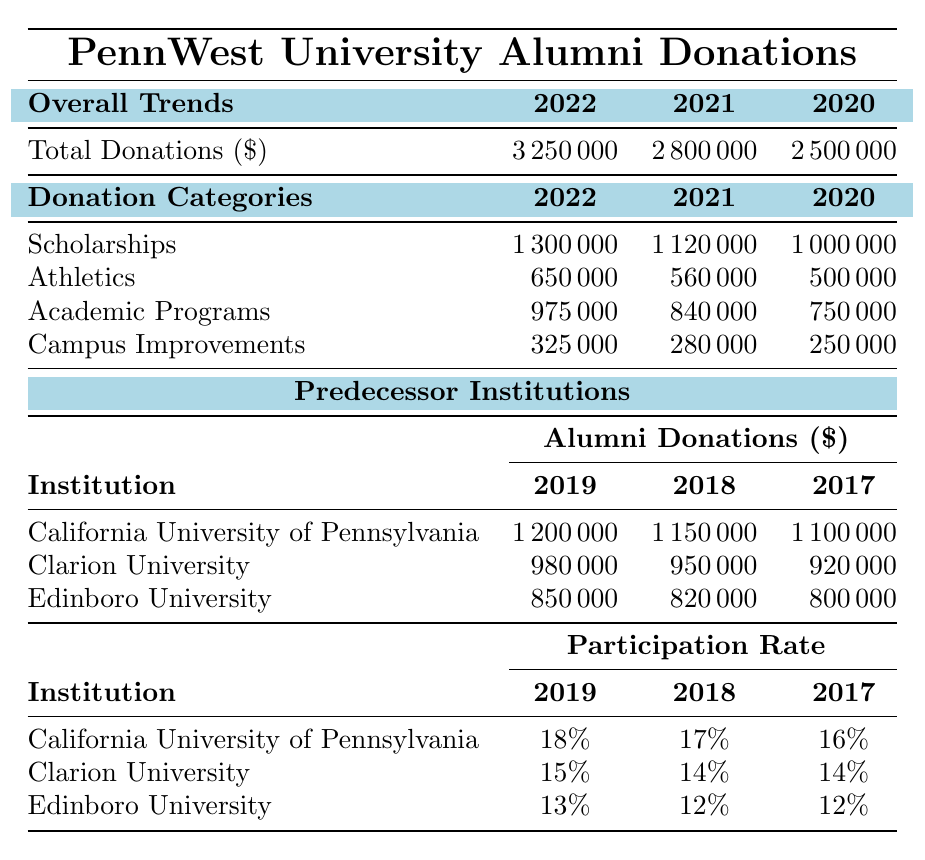What was the total alumni donation for PennWest University in 2022? The table indicates that the total alumni donations for PennWest University in 2022 is listed as $3,250,000.
Answer: $3,250,000 What was the participation rate for California University of Pennsylvania in 2019? The participation rate for California University of Pennsylvania in 2019 is shown in the table as 18%.
Answer: 18% Which predecessor institution received the lowest total donations in 2017? By comparing the total donations listed for the institutions in 2017, Edinboro University received the lowest amount at $800,000.
Answer: Edinboro University What is the difference in total donations between PennWest University in 2022 and 2021? To find the difference, subtract the 2021 total donations ($2,800,000) from the 2022 total donations ($3,250,000), which gives $3,250,000 - $2,800,000 = $450,000.
Answer: $450,000 What was the average alumni donation for Clarion University from 2017 to 2019? The total donations for Clarion University over the three years are $920,000 (2017) + $950,000 (2018) + $980,000 (2019) = $2,850,000. Dividing this sum by 3 gives an average of $2,850,000 / 3 = $950,000.
Answer: $950,000 Did Edinboro University have a participation rate higher than 12% in 2018? According to the table, Edinboro University's participation rate in 2018 was 12%, which is not higher than 12%.
Answer: No What is the total amount donated to scholarships from 2020 to 2022? The total donations to scholarships for the years 2020, 2021, and 2022 are $1,000,000 + $1,120,000 + $1,300,000 = $3,420,000.
Answer: $3,420,000 Which year saw the highest total alumni donations for California University of Pennsylvania? The highest total alumni donations for California University of Pennsylvania were in 2019, with donations amounting to $1,200,000, which is greater than the amounts for 2018 and 2017.
Answer: 2019 What percentage increase in donations did PennWest University experience from 2020 to 2022? To calculate the percentage increase, find the difference between the 2022 total ($3,250,000) and the 2020 total ($2,500,000), which is $3,250,000 - $2,500,000 = $750,000. Then divide by the 2020 total and multiply by 100: ($750,000 / $2,500,000) * 100 = 30%.
Answer: 30% Is there a clear trend in alumni donations for Campus Improvements over the three years shown? By examining the table, the donations for Campus Improvements are listed as decreasing from $250,000 in 2020 to $280,000 in 2021, then to $325,000 in 2022, indicating a trend of overall increase.
Answer: Yes 